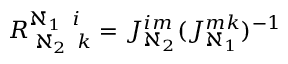<formula> <loc_0><loc_0><loc_500><loc_500>R _ { \, \aleph _ { 2 } \, k } ^ { \aleph _ { 1 } \, i } = J _ { \aleph _ { 2 } } ^ { i m } ( J _ { \aleph _ { 1 } } ^ { m k } ) ^ { - 1 }</formula> 